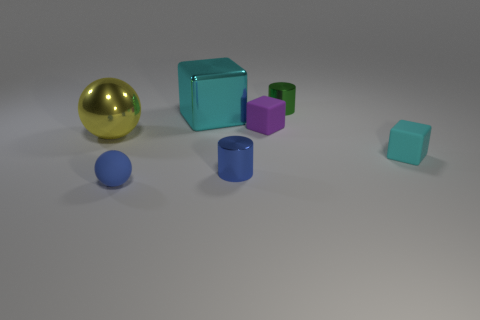What is the material of the tiny cube that is the same color as the large block? While I cannot determine the exact material of objects in an image, the tiny cube that shares the teal color with the larger block suggests that, within the context of this image, it is likely intended to represent the same material. Typically, in real-world settings, such objects might be made of plastic or wood, depending on their use and design. 